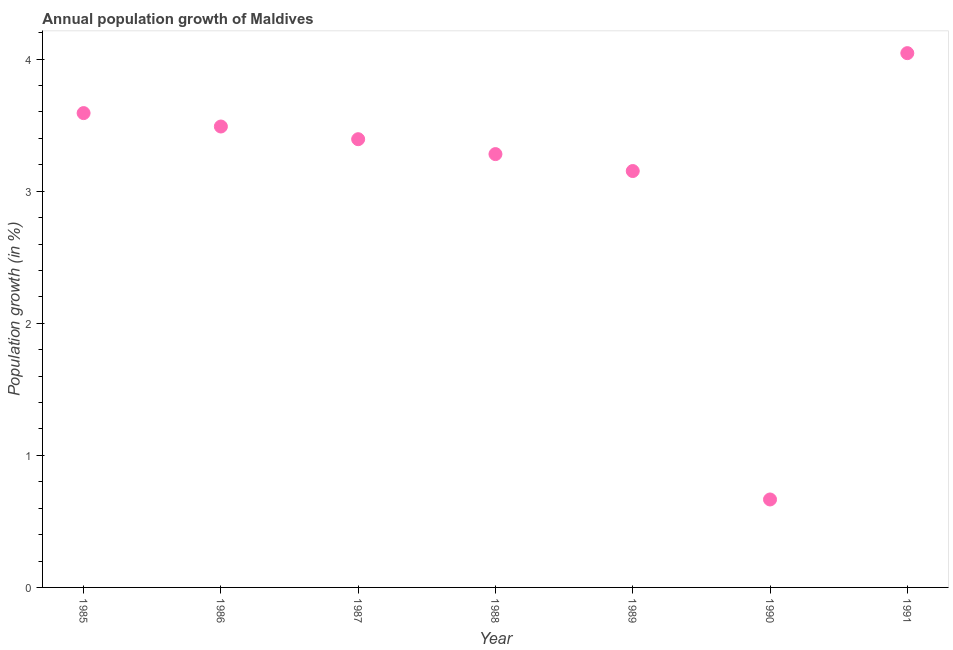What is the population growth in 1989?
Provide a short and direct response. 3.15. Across all years, what is the maximum population growth?
Give a very brief answer. 4.05. Across all years, what is the minimum population growth?
Provide a short and direct response. 0.67. In which year was the population growth maximum?
Your answer should be compact. 1991. In which year was the population growth minimum?
Provide a short and direct response. 1990. What is the sum of the population growth?
Offer a very short reply. 21.62. What is the difference between the population growth in 1986 and 1991?
Make the answer very short. -0.56. What is the average population growth per year?
Offer a terse response. 3.09. What is the median population growth?
Provide a short and direct response. 3.39. What is the ratio of the population growth in 1986 to that in 1987?
Give a very brief answer. 1.03. Is the population growth in 1989 less than that in 1990?
Your answer should be compact. No. Is the difference between the population growth in 1986 and 1990 greater than the difference between any two years?
Provide a short and direct response. No. What is the difference between the highest and the second highest population growth?
Make the answer very short. 0.45. What is the difference between the highest and the lowest population growth?
Make the answer very short. 3.38. Does the population growth monotonically increase over the years?
Provide a short and direct response. No. How many dotlines are there?
Provide a succinct answer. 1. What is the difference between two consecutive major ticks on the Y-axis?
Your answer should be compact. 1. What is the title of the graph?
Keep it short and to the point. Annual population growth of Maldives. What is the label or title of the Y-axis?
Offer a terse response. Population growth (in %). What is the Population growth (in %) in 1985?
Your answer should be compact. 3.59. What is the Population growth (in %) in 1986?
Offer a very short reply. 3.49. What is the Population growth (in %) in 1987?
Your answer should be compact. 3.39. What is the Population growth (in %) in 1988?
Offer a terse response. 3.28. What is the Population growth (in %) in 1989?
Provide a succinct answer. 3.15. What is the Population growth (in %) in 1990?
Your answer should be very brief. 0.67. What is the Population growth (in %) in 1991?
Your answer should be compact. 4.05. What is the difference between the Population growth (in %) in 1985 and 1986?
Make the answer very short. 0.1. What is the difference between the Population growth (in %) in 1985 and 1987?
Keep it short and to the point. 0.2. What is the difference between the Population growth (in %) in 1985 and 1988?
Your response must be concise. 0.31. What is the difference between the Population growth (in %) in 1985 and 1989?
Offer a very short reply. 0.44. What is the difference between the Population growth (in %) in 1985 and 1990?
Your response must be concise. 2.93. What is the difference between the Population growth (in %) in 1985 and 1991?
Provide a succinct answer. -0.45. What is the difference between the Population growth (in %) in 1986 and 1987?
Offer a very short reply. 0.1. What is the difference between the Population growth (in %) in 1986 and 1988?
Keep it short and to the point. 0.21. What is the difference between the Population growth (in %) in 1986 and 1989?
Your answer should be very brief. 0.34. What is the difference between the Population growth (in %) in 1986 and 1990?
Offer a terse response. 2.82. What is the difference between the Population growth (in %) in 1986 and 1991?
Make the answer very short. -0.56. What is the difference between the Population growth (in %) in 1987 and 1988?
Make the answer very short. 0.11. What is the difference between the Population growth (in %) in 1987 and 1989?
Offer a terse response. 0.24. What is the difference between the Population growth (in %) in 1987 and 1990?
Give a very brief answer. 2.73. What is the difference between the Population growth (in %) in 1987 and 1991?
Provide a succinct answer. -0.65. What is the difference between the Population growth (in %) in 1988 and 1989?
Provide a succinct answer. 0.13. What is the difference between the Population growth (in %) in 1988 and 1990?
Give a very brief answer. 2.62. What is the difference between the Population growth (in %) in 1988 and 1991?
Offer a very short reply. -0.76. What is the difference between the Population growth (in %) in 1989 and 1990?
Your answer should be very brief. 2.49. What is the difference between the Population growth (in %) in 1989 and 1991?
Provide a succinct answer. -0.89. What is the difference between the Population growth (in %) in 1990 and 1991?
Keep it short and to the point. -3.38. What is the ratio of the Population growth (in %) in 1985 to that in 1986?
Give a very brief answer. 1.03. What is the ratio of the Population growth (in %) in 1985 to that in 1987?
Make the answer very short. 1.06. What is the ratio of the Population growth (in %) in 1985 to that in 1988?
Ensure brevity in your answer.  1.09. What is the ratio of the Population growth (in %) in 1985 to that in 1989?
Keep it short and to the point. 1.14. What is the ratio of the Population growth (in %) in 1985 to that in 1990?
Your response must be concise. 5.39. What is the ratio of the Population growth (in %) in 1985 to that in 1991?
Your answer should be compact. 0.89. What is the ratio of the Population growth (in %) in 1986 to that in 1987?
Your response must be concise. 1.03. What is the ratio of the Population growth (in %) in 1986 to that in 1988?
Your answer should be compact. 1.06. What is the ratio of the Population growth (in %) in 1986 to that in 1989?
Your response must be concise. 1.11. What is the ratio of the Population growth (in %) in 1986 to that in 1990?
Provide a short and direct response. 5.24. What is the ratio of the Population growth (in %) in 1986 to that in 1991?
Keep it short and to the point. 0.86. What is the ratio of the Population growth (in %) in 1987 to that in 1988?
Your answer should be compact. 1.03. What is the ratio of the Population growth (in %) in 1987 to that in 1989?
Offer a very short reply. 1.08. What is the ratio of the Population growth (in %) in 1987 to that in 1990?
Your answer should be compact. 5.1. What is the ratio of the Population growth (in %) in 1987 to that in 1991?
Your answer should be very brief. 0.84. What is the ratio of the Population growth (in %) in 1988 to that in 1989?
Offer a terse response. 1.04. What is the ratio of the Population growth (in %) in 1988 to that in 1990?
Ensure brevity in your answer.  4.93. What is the ratio of the Population growth (in %) in 1988 to that in 1991?
Give a very brief answer. 0.81. What is the ratio of the Population growth (in %) in 1989 to that in 1990?
Your response must be concise. 4.73. What is the ratio of the Population growth (in %) in 1989 to that in 1991?
Keep it short and to the point. 0.78. What is the ratio of the Population growth (in %) in 1990 to that in 1991?
Your answer should be very brief. 0.17. 